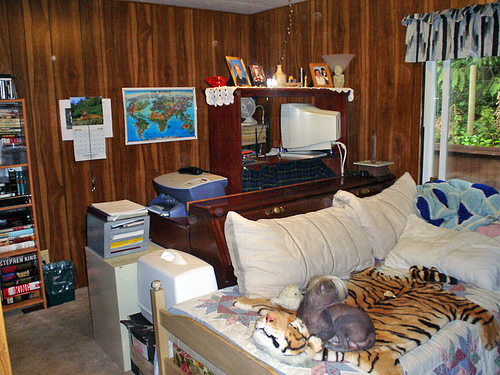Please identify all text content in this image. KING 